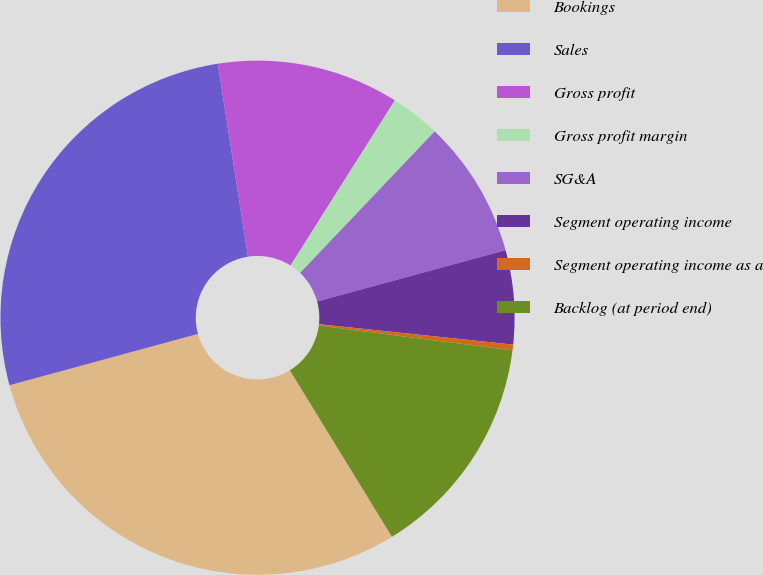Convert chart to OTSL. <chart><loc_0><loc_0><loc_500><loc_500><pie_chart><fcel>Bookings<fcel>Sales<fcel>Gross profit<fcel>Gross profit margin<fcel>SG&A<fcel>Segment operating income<fcel>Segment operating income as a<fcel>Backlog (at period end)<nl><fcel>29.53%<fcel>26.76%<fcel>11.44%<fcel>3.13%<fcel>8.67%<fcel>5.9%<fcel>0.36%<fcel>14.21%<nl></chart> 